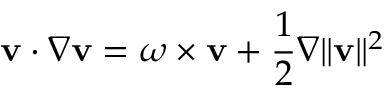<formula> <loc_0><loc_0><loc_500><loc_500>{ v } \cdot \nabla { v } = \omega \times { v } + { \frac { 1 } { 2 } } \nabla \| { v } \| ^ { 2 }</formula> 